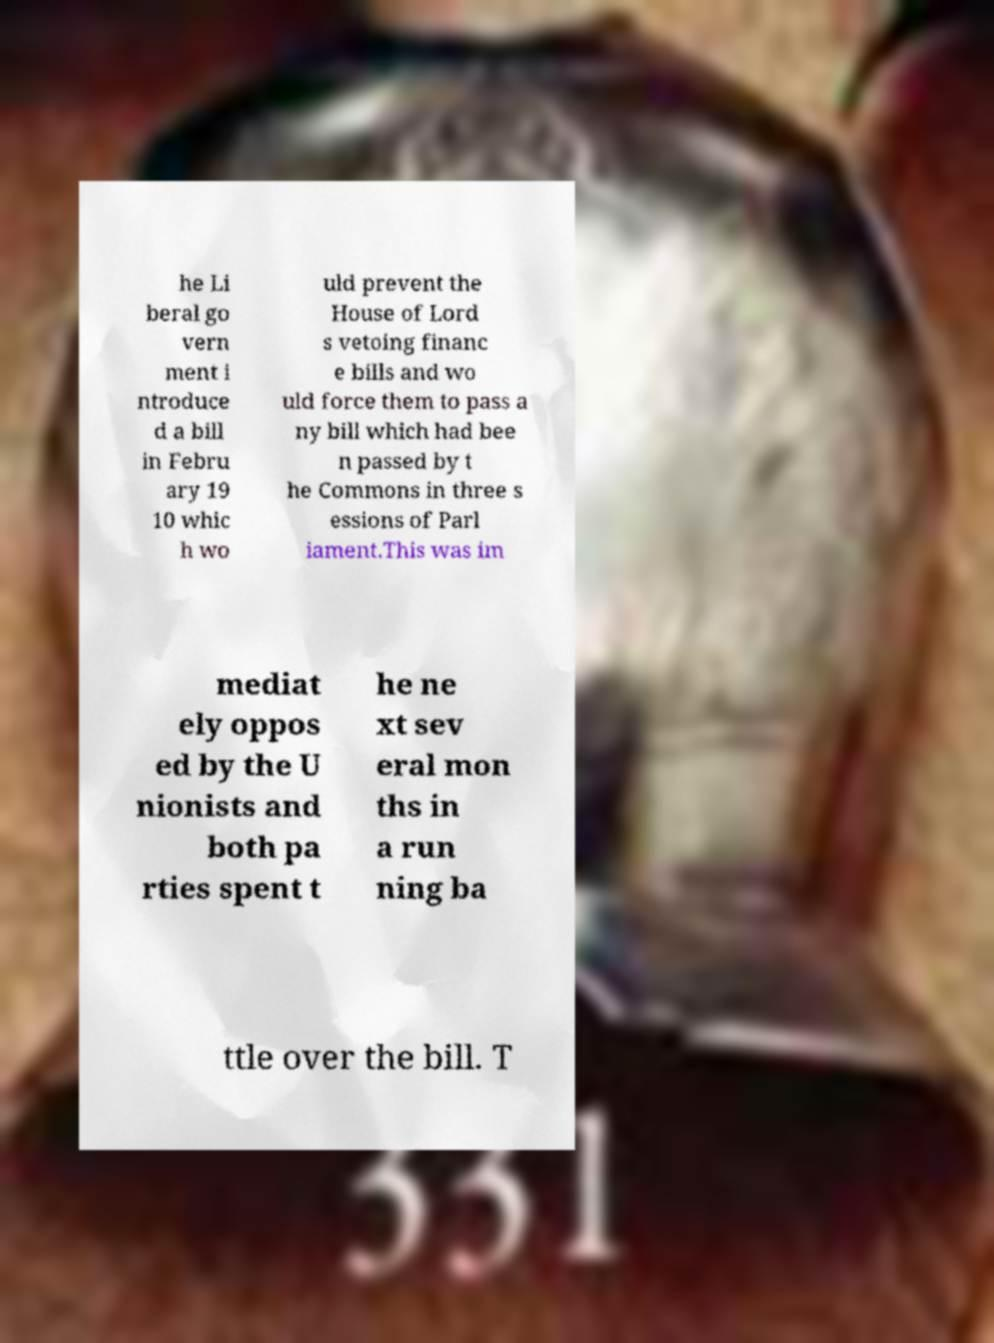Can you accurately transcribe the text from the provided image for me? he Li beral go vern ment i ntroduce d a bill in Febru ary 19 10 whic h wo uld prevent the House of Lord s vetoing financ e bills and wo uld force them to pass a ny bill which had bee n passed by t he Commons in three s essions of Parl iament.This was im mediat ely oppos ed by the U nionists and both pa rties spent t he ne xt sev eral mon ths in a run ning ba ttle over the bill. T 